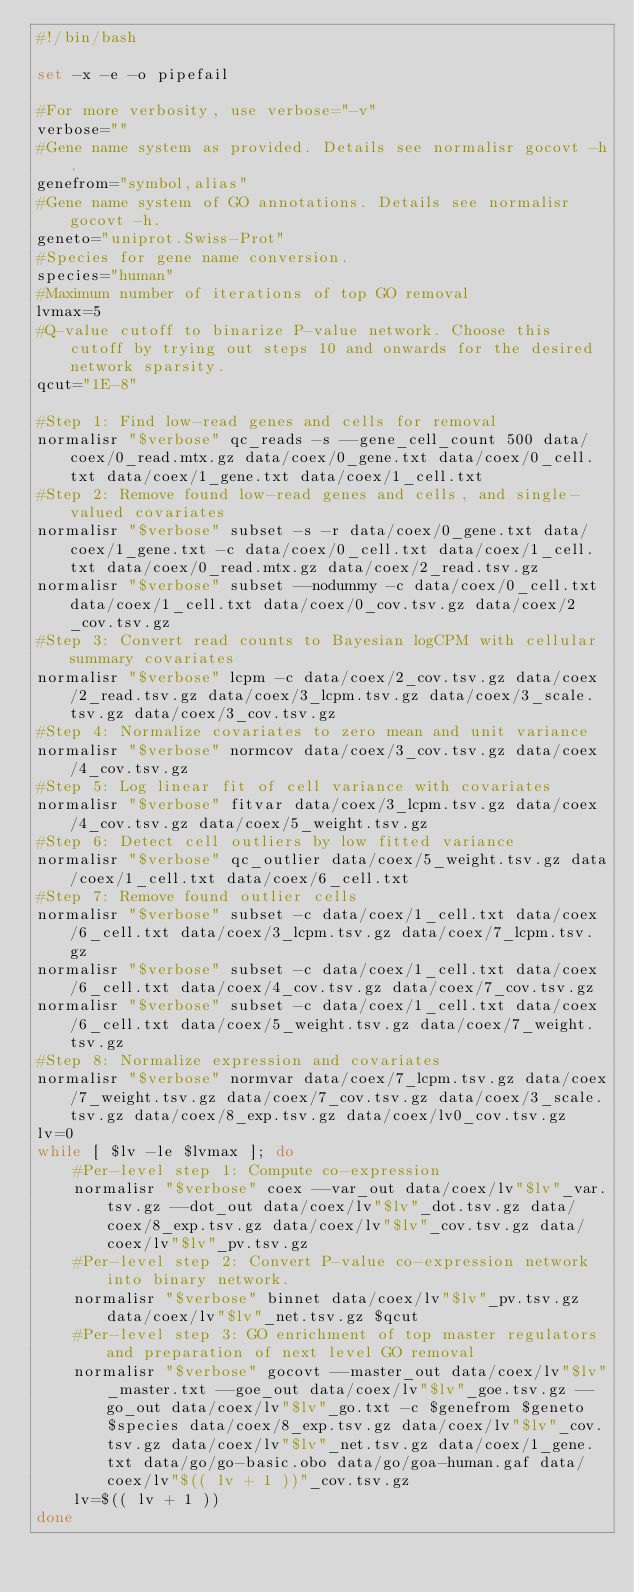Convert code to text. <code><loc_0><loc_0><loc_500><loc_500><_Bash_>#!/bin/bash

set -x -e -o pipefail

#For more verbosity, use verbose="-v"
verbose=""
#Gene name system as provided. Details see normalisr gocovt -h.
genefrom="symbol,alias"
#Gene name system of GO annotations. Details see normalisr gocovt -h.
geneto="uniprot.Swiss-Prot"
#Species for gene name conversion.
species="human"
#Maximum number of iterations of top GO removal
lvmax=5
#Q-value cutoff to binarize P-value network. Choose this cutoff by trying out steps 10 and onwards for the desired network sparsity.
qcut="1E-8"

#Step 1: Find low-read genes and cells for removal
normalisr "$verbose" qc_reads -s --gene_cell_count 500 data/coex/0_read.mtx.gz data/coex/0_gene.txt data/coex/0_cell.txt data/coex/1_gene.txt data/coex/1_cell.txt
#Step 2: Remove found low-read genes and cells, and single-valued covariates
normalisr "$verbose" subset -s -r data/coex/0_gene.txt data/coex/1_gene.txt -c data/coex/0_cell.txt data/coex/1_cell.txt data/coex/0_read.mtx.gz data/coex/2_read.tsv.gz
normalisr "$verbose" subset --nodummy -c data/coex/0_cell.txt data/coex/1_cell.txt data/coex/0_cov.tsv.gz data/coex/2_cov.tsv.gz
#Step 3: Convert read counts to Bayesian logCPM with cellular summary covariates
normalisr "$verbose" lcpm -c data/coex/2_cov.tsv.gz data/coex/2_read.tsv.gz data/coex/3_lcpm.tsv.gz data/coex/3_scale.tsv.gz data/coex/3_cov.tsv.gz
#Step 4: Normalize covariates to zero mean and unit variance
normalisr "$verbose" normcov data/coex/3_cov.tsv.gz data/coex/4_cov.tsv.gz
#Step 5: Log linear fit of cell variance with covariates
normalisr "$verbose" fitvar data/coex/3_lcpm.tsv.gz data/coex/4_cov.tsv.gz data/coex/5_weight.tsv.gz
#Step 6: Detect cell outliers by low fitted variance
normalisr "$verbose" qc_outlier data/coex/5_weight.tsv.gz data/coex/1_cell.txt data/coex/6_cell.txt
#Step 7: Remove found outlier cells
normalisr "$verbose" subset -c data/coex/1_cell.txt data/coex/6_cell.txt data/coex/3_lcpm.tsv.gz data/coex/7_lcpm.tsv.gz
normalisr "$verbose" subset -c data/coex/1_cell.txt data/coex/6_cell.txt data/coex/4_cov.tsv.gz data/coex/7_cov.tsv.gz
normalisr "$verbose" subset -c data/coex/1_cell.txt data/coex/6_cell.txt data/coex/5_weight.tsv.gz data/coex/7_weight.tsv.gz
#Step 8: Normalize expression and covariates
normalisr "$verbose" normvar data/coex/7_lcpm.tsv.gz data/coex/7_weight.tsv.gz data/coex/7_cov.tsv.gz data/coex/3_scale.tsv.gz data/coex/8_exp.tsv.gz data/coex/lv0_cov.tsv.gz
lv=0
while [ $lv -le $lvmax ]; do
	#Per-level step 1: Compute co-expression
	normalisr "$verbose" coex --var_out data/coex/lv"$lv"_var.tsv.gz --dot_out data/coex/lv"$lv"_dot.tsv.gz data/coex/8_exp.tsv.gz data/coex/lv"$lv"_cov.tsv.gz data/coex/lv"$lv"_pv.tsv.gz
	#Per-level step 2: Convert P-value co-expression network into binary network. 
	normalisr "$verbose" binnet data/coex/lv"$lv"_pv.tsv.gz data/coex/lv"$lv"_net.tsv.gz $qcut
	#Per-level step 3: GO enrichment of top master regulators and preparation of next level GO removal
	normalisr "$verbose" gocovt --master_out data/coex/lv"$lv"_master.txt --goe_out data/coex/lv"$lv"_goe.tsv.gz --go_out data/coex/lv"$lv"_go.txt -c $genefrom $geneto $species data/coex/8_exp.tsv.gz data/coex/lv"$lv"_cov.tsv.gz data/coex/lv"$lv"_net.tsv.gz data/coex/1_gene.txt data/go/go-basic.obo data/go/goa-human.gaf data/coex/lv"$(( lv + 1 ))"_cov.tsv.gz
	lv=$(( lv + 1 ))
done
</code> 